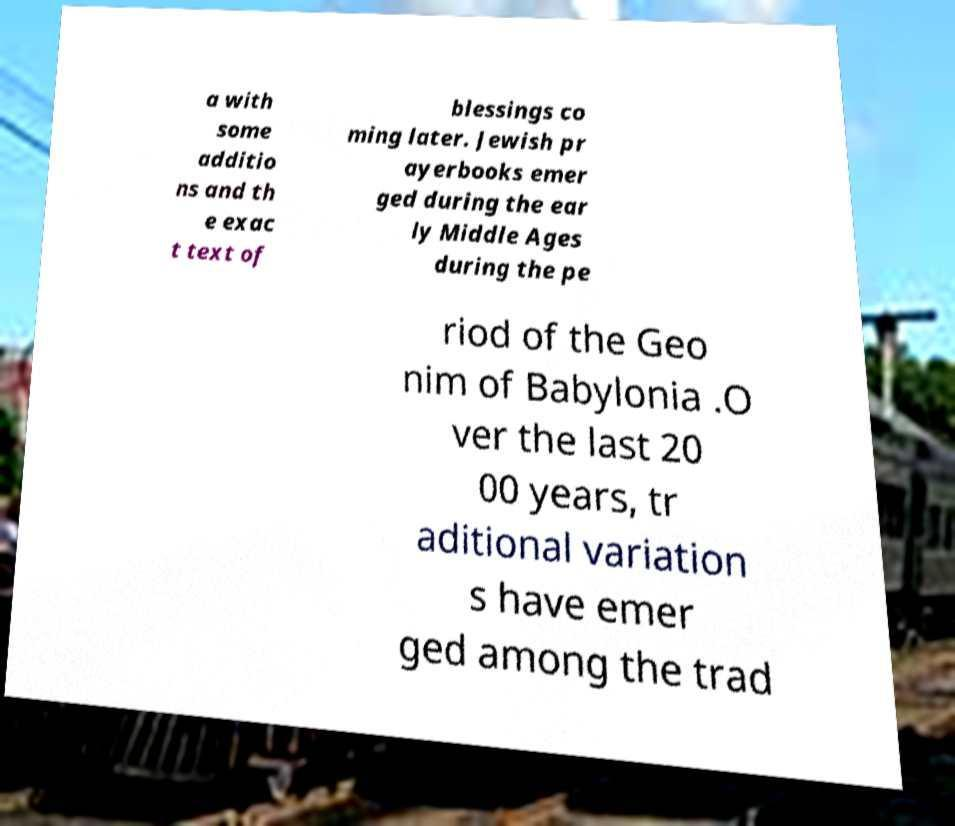What messages or text are displayed in this image? I need them in a readable, typed format. a with some additio ns and th e exac t text of blessings co ming later. Jewish pr ayerbooks emer ged during the ear ly Middle Ages during the pe riod of the Geo nim of Babylonia .O ver the last 20 00 years, tr aditional variation s have emer ged among the trad 